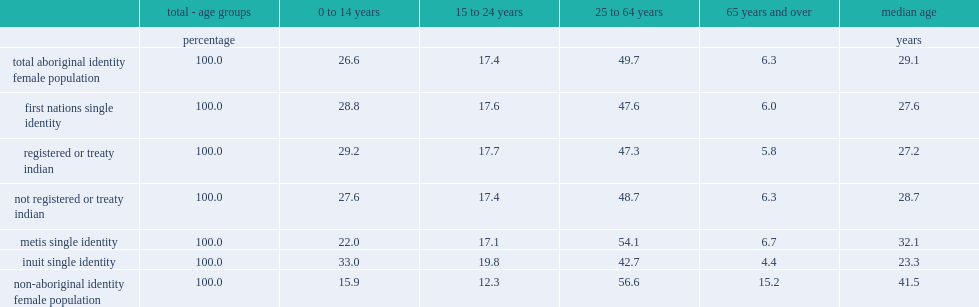What was the median age of aboriginal females? 29.1. What was the median age of non-aboriginal females? 41.5. What was the median age of inuit females? 23.3. What was the median age of metis females? 32.1. Among first nations females, what was the median age for those with registered indian status? 27.2. Among first nations females, what was the median age for those without registered indian status? 28.7. In 2011, what was the percent of aboriginal females were girls aged 14 and under? 26.6. In 2011, what was the percent of non-aboriginal females were girls aged 14 and under? 15.9. What was the percent of inuit females were aged 14 and under? 33.0. What was the proportions for first nations females aged 14 and under? 28.8. What was the proportions for metis females aged 14 and under? 22.0. In terms of senior aboriginal women, how many percent were aged 65 and over? 6.3. What was the percent of the non-aboriginal female population in 2011? 15.2. What was the percent of inuit women were 65 years and over? 4.4. What was the percent of first nations women were 65 years and over? 6.0. What was the percent of metis women were 65 years and over? 6.7. 